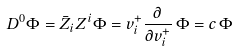<formula> <loc_0><loc_0><loc_500><loc_500>D ^ { 0 } \Phi = \bar { Z } _ { i } Z ^ { i } \Phi = v ^ { + } _ { i } \frac { \partial } { \partial v ^ { + } _ { i } } \, \Phi = c \, \Phi</formula> 